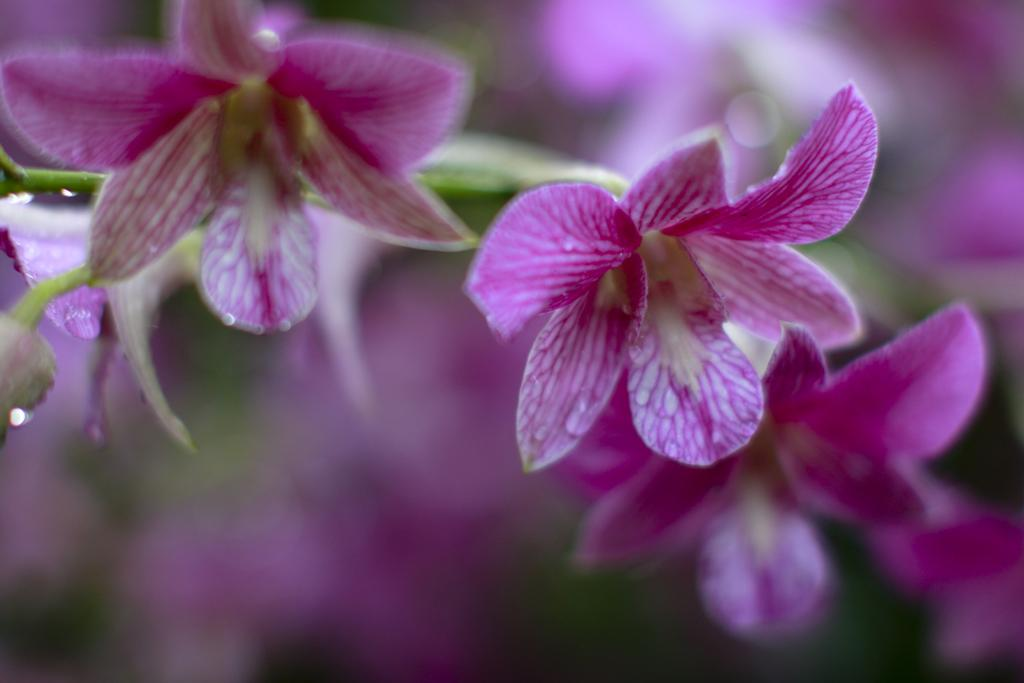What type of flowers are in the image? There are purple orchids in the image. How many arches can be seen supporting the kittens in the image? There are no arches or kittens present in the image; it features purple orchids. 